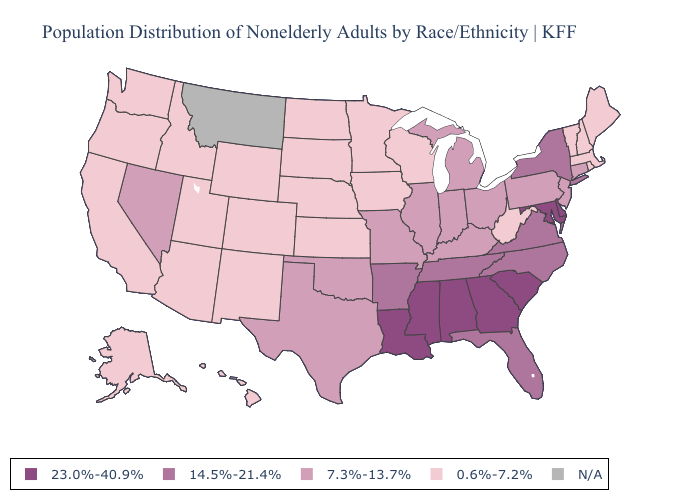Does the first symbol in the legend represent the smallest category?
Keep it brief. No. Name the states that have a value in the range 0.6%-7.2%?
Answer briefly. Alaska, Arizona, California, Colorado, Hawaii, Idaho, Iowa, Kansas, Maine, Massachusetts, Minnesota, Nebraska, New Hampshire, New Mexico, North Dakota, Oregon, Rhode Island, South Dakota, Utah, Vermont, Washington, West Virginia, Wisconsin, Wyoming. Which states have the highest value in the USA?
Keep it brief. Alabama, Delaware, Georgia, Louisiana, Maryland, Mississippi, South Carolina. Does Virginia have the lowest value in the USA?
Concise answer only. No. Does Mississippi have the highest value in the USA?
Give a very brief answer. Yes. What is the value of Delaware?
Concise answer only. 23.0%-40.9%. Name the states that have a value in the range 0.6%-7.2%?
Quick response, please. Alaska, Arizona, California, Colorado, Hawaii, Idaho, Iowa, Kansas, Maine, Massachusetts, Minnesota, Nebraska, New Hampshire, New Mexico, North Dakota, Oregon, Rhode Island, South Dakota, Utah, Vermont, Washington, West Virginia, Wisconsin, Wyoming. Name the states that have a value in the range N/A?
Keep it brief. Montana. What is the lowest value in the USA?
Keep it brief. 0.6%-7.2%. Which states have the highest value in the USA?
Be succinct. Alabama, Delaware, Georgia, Louisiana, Maryland, Mississippi, South Carolina. What is the highest value in the MidWest ?
Write a very short answer. 7.3%-13.7%. Among the states that border Minnesota , which have the highest value?
Answer briefly. Iowa, North Dakota, South Dakota, Wisconsin. Does Georgia have the highest value in the USA?
Keep it brief. Yes. What is the highest value in states that border Iowa?
Write a very short answer. 7.3%-13.7%. 